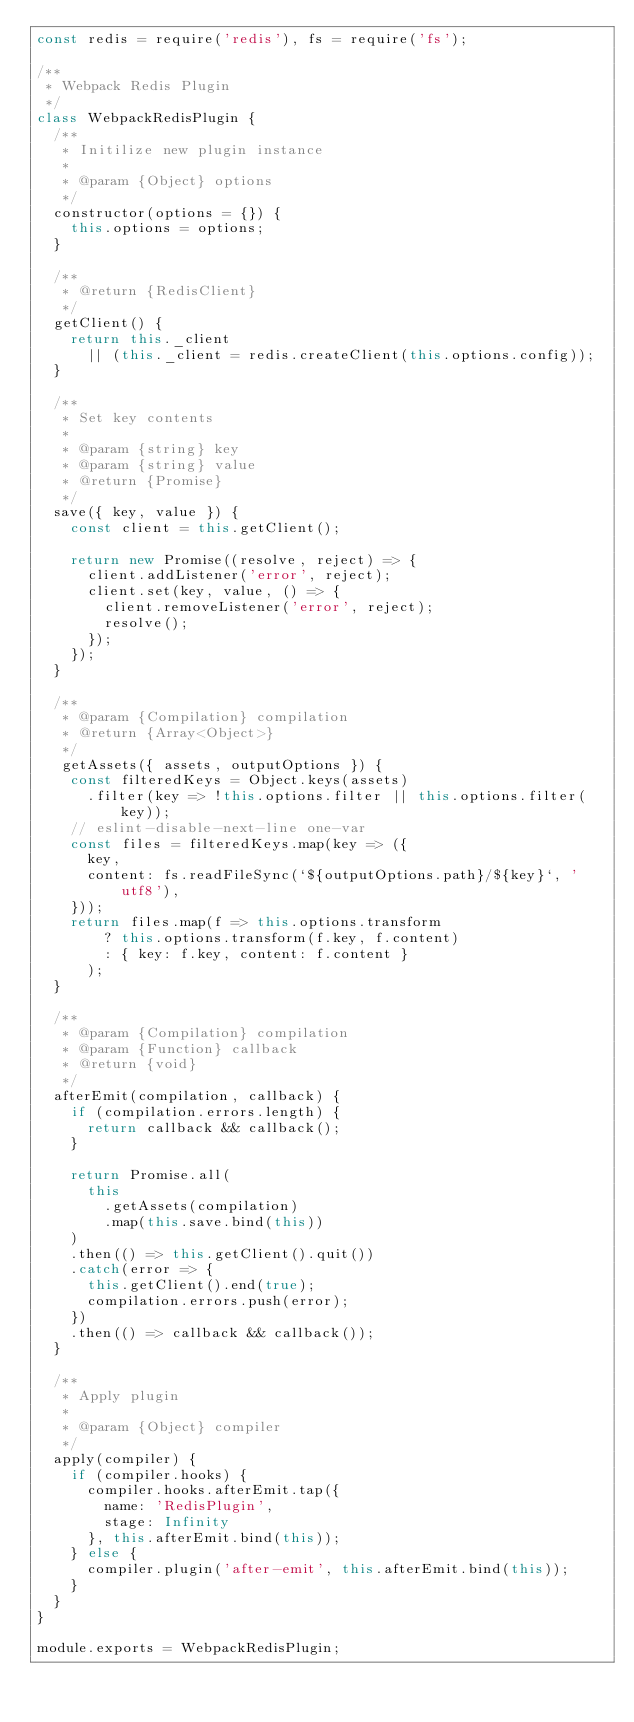<code> <loc_0><loc_0><loc_500><loc_500><_JavaScript_>const redis = require('redis'), fs = require('fs');

/**
 * Webpack Redis Plugin
 */
class WebpackRedisPlugin {
  /**
   * Initilize new plugin instance
   *
   * @param {Object} options
   */
  constructor(options = {}) {
    this.options = options;
  }

  /**
   * @return {RedisClient}
   */
  getClient() {
    return this._client
      || (this._client = redis.createClient(this.options.config));
  }

  /**
   * Set key contents
   *
   * @param {string} key
   * @param {string} value
   * @return {Promise}
   */
  save({ key, value }) {
    const client = this.getClient();

    return new Promise((resolve, reject) => {
      client.addListener('error', reject);
      client.set(key, value, () => {
        client.removeListener('error', reject);
        resolve();
      });
    });
  }

  /**
   * @param {Compilation} compilation
   * @return {Array<Object>}
   */
   getAssets({ assets, outputOptions }) {
    const filteredKeys = Object.keys(assets)
      .filter(key => !this.options.filter || this.options.filter(key));
    // eslint-disable-next-line one-var
    const files = filteredKeys.map(key => ({
      key,
      content: fs.readFileSync(`${outputOptions.path}/${key}`, 'utf8'),
    }));
    return files.map(f => this.options.transform
        ? this.options.transform(f.key, f.content)
        : { key: f.key, content: f.content }
      );
  }

  /**
   * @param {Compilation} compilation
   * @param {Function} callback
   * @return {void}
   */
  afterEmit(compilation, callback) {
    if (compilation.errors.length) {
      return callback && callback();
    }

    return Promise.all(
      this
        .getAssets(compilation)
        .map(this.save.bind(this))
    )
    .then(() => this.getClient().quit())
    .catch(error => {
      this.getClient().end(true);
      compilation.errors.push(error);
    })
    .then(() => callback && callback());
  }

  /**
   * Apply plugin
   *
   * @param {Object} compiler
   */
  apply(compiler) {
    if (compiler.hooks) {
      compiler.hooks.afterEmit.tap({
        name: 'RedisPlugin',
        stage: Infinity
      }, this.afterEmit.bind(this));
    } else {
      compiler.plugin('after-emit', this.afterEmit.bind(this));
    }
  }
}

module.exports = WebpackRedisPlugin;
</code> 